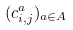<formula> <loc_0><loc_0><loc_500><loc_500>( c _ { i , j } ^ { a } ) _ { a \in A }</formula> 